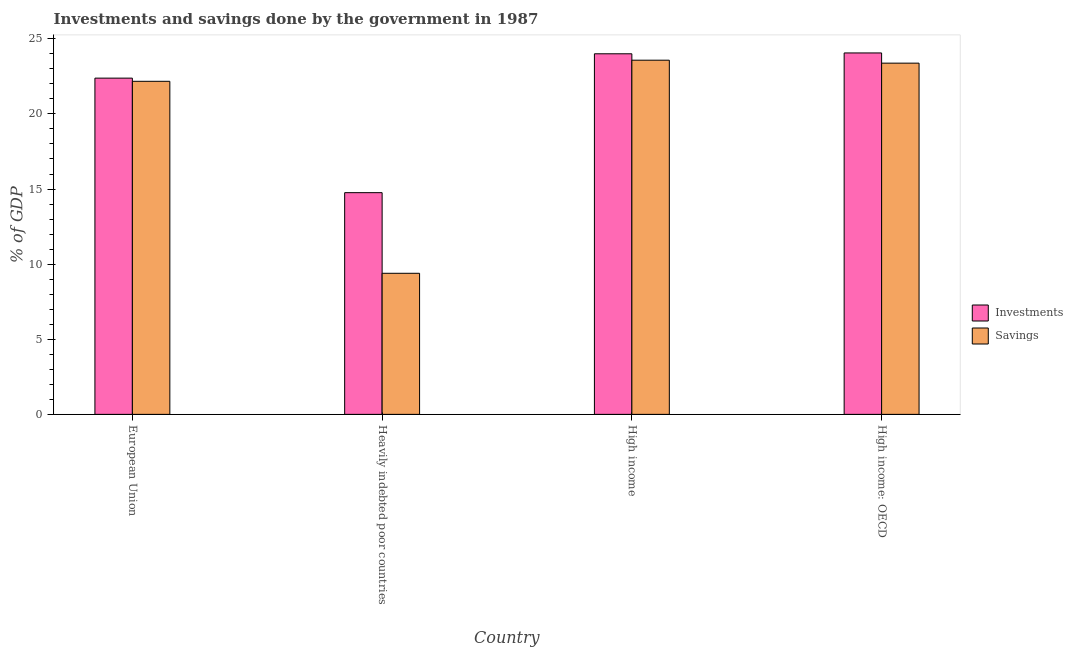How many different coloured bars are there?
Provide a short and direct response. 2. Are the number of bars per tick equal to the number of legend labels?
Provide a short and direct response. Yes. Are the number of bars on each tick of the X-axis equal?
Offer a very short reply. Yes. How many bars are there on the 2nd tick from the right?
Make the answer very short. 2. What is the label of the 2nd group of bars from the left?
Keep it short and to the point. Heavily indebted poor countries. What is the savings of government in High income: OECD?
Give a very brief answer. 23.38. Across all countries, what is the maximum savings of government?
Your response must be concise. 23.58. Across all countries, what is the minimum savings of government?
Ensure brevity in your answer.  9.39. In which country was the investments of government maximum?
Your response must be concise. High income: OECD. In which country was the savings of government minimum?
Offer a very short reply. Heavily indebted poor countries. What is the total investments of government in the graph?
Offer a very short reply. 85.21. What is the difference between the investments of government in European Union and that in High income: OECD?
Provide a succinct answer. -1.68. What is the difference between the investments of government in European Union and the savings of government in Heavily indebted poor countries?
Offer a terse response. 12.99. What is the average investments of government per country?
Your answer should be very brief. 21.3. What is the difference between the investments of government and savings of government in High income?
Keep it short and to the point. 0.43. What is the ratio of the savings of government in European Union to that in High income: OECD?
Make the answer very short. 0.95. Is the savings of government in European Union less than that in High income: OECD?
Provide a short and direct response. Yes. What is the difference between the highest and the second highest savings of government?
Your answer should be very brief. 0.2. What is the difference between the highest and the lowest savings of government?
Your answer should be very brief. 14.19. In how many countries, is the savings of government greater than the average savings of government taken over all countries?
Keep it short and to the point. 3. What does the 1st bar from the left in High income: OECD represents?
Provide a short and direct response. Investments. What does the 2nd bar from the right in High income represents?
Make the answer very short. Investments. How many bars are there?
Your response must be concise. 8. What is the difference between two consecutive major ticks on the Y-axis?
Ensure brevity in your answer.  5. Does the graph contain grids?
Give a very brief answer. No. How many legend labels are there?
Make the answer very short. 2. How are the legend labels stacked?
Your response must be concise. Vertical. What is the title of the graph?
Offer a terse response. Investments and savings done by the government in 1987. Does "Net National savings" appear as one of the legend labels in the graph?
Ensure brevity in your answer.  No. What is the label or title of the X-axis?
Your answer should be compact. Country. What is the label or title of the Y-axis?
Offer a very short reply. % of GDP. What is the % of GDP in Investments in European Union?
Keep it short and to the point. 22.38. What is the % of GDP of Savings in European Union?
Offer a terse response. 22.17. What is the % of GDP of Investments in Heavily indebted poor countries?
Provide a short and direct response. 14.76. What is the % of GDP of Savings in Heavily indebted poor countries?
Provide a short and direct response. 9.39. What is the % of GDP of Investments in High income?
Your answer should be very brief. 24. What is the % of GDP of Savings in High income?
Your answer should be compact. 23.58. What is the % of GDP in Investments in High income: OECD?
Keep it short and to the point. 24.06. What is the % of GDP of Savings in High income: OECD?
Keep it short and to the point. 23.38. Across all countries, what is the maximum % of GDP in Investments?
Your response must be concise. 24.06. Across all countries, what is the maximum % of GDP of Savings?
Your response must be concise. 23.58. Across all countries, what is the minimum % of GDP in Investments?
Your response must be concise. 14.76. Across all countries, what is the minimum % of GDP in Savings?
Keep it short and to the point. 9.39. What is the total % of GDP in Investments in the graph?
Offer a terse response. 85.2. What is the total % of GDP of Savings in the graph?
Your response must be concise. 78.52. What is the difference between the % of GDP of Investments in European Union and that in Heavily indebted poor countries?
Make the answer very short. 7.62. What is the difference between the % of GDP in Savings in European Union and that in Heavily indebted poor countries?
Your answer should be compact. 12.78. What is the difference between the % of GDP in Investments in European Union and that in High income?
Your answer should be compact. -1.62. What is the difference between the % of GDP in Savings in European Union and that in High income?
Ensure brevity in your answer.  -1.41. What is the difference between the % of GDP of Investments in European Union and that in High income: OECD?
Provide a succinct answer. -1.68. What is the difference between the % of GDP in Savings in European Union and that in High income: OECD?
Provide a succinct answer. -1.21. What is the difference between the % of GDP in Investments in Heavily indebted poor countries and that in High income?
Keep it short and to the point. -9.24. What is the difference between the % of GDP in Savings in Heavily indebted poor countries and that in High income?
Your answer should be very brief. -14.19. What is the difference between the % of GDP in Investments in Heavily indebted poor countries and that in High income: OECD?
Make the answer very short. -9.3. What is the difference between the % of GDP in Savings in Heavily indebted poor countries and that in High income: OECD?
Make the answer very short. -13.99. What is the difference between the % of GDP in Investments in High income and that in High income: OECD?
Make the answer very short. -0.06. What is the difference between the % of GDP of Savings in High income and that in High income: OECD?
Ensure brevity in your answer.  0.2. What is the difference between the % of GDP of Investments in European Union and the % of GDP of Savings in Heavily indebted poor countries?
Keep it short and to the point. 12.99. What is the difference between the % of GDP in Investments in European Union and the % of GDP in Savings in High income?
Your answer should be very brief. -1.19. What is the difference between the % of GDP of Investments in European Union and the % of GDP of Savings in High income: OECD?
Your response must be concise. -1. What is the difference between the % of GDP of Investments in Heavily indebted poor countries and the % of GDP of Savings in High income?
Your answer should be very brief. -8.82. What is the difference between the % of GDP of Investments in Heavily indebted poor countries and the % of GDP of Savings in High income: OECD?
Provide a short and direct response. -8.62. What is the difference between the % of GDP of Investments in High income and the % of GDP of Savings in High income: OECD?
Provide a short and direct response. 0.62. What is the average % of GDP in Investments per country?
Provide a succinct answer. 21.3. What is the average % of GDP in Savings per country?
Your answer should be compact. 19.63. What is the difference between the % of GDP of Investments and % of GDP of Savings in European Union?
Give a very brief answer. 0.21. What is the difference between the % of GDP in Investments and % of GDP in Savings in Heavily indebted poor countries?
Give a very brief answer. 5.37. What is the difference between the % of GDP in Investments and % of GDP in Savings in High income?
Your answer should be compact. 0.43. What is the difference between the % of GDP in Investments and % of GDP in Savings in High income: OECD?
Offer a very short reply. 0.68. What is the ratio of the % of GDP of Investments in European Union to that in Heavily indebted poor countries?
Keep it short and to the point. 1.52. What is the ratio of the % of GDP of Savings in European Union to that in Heavily indebted poor countries?
Provide a succinct answer. 2.36. What is the ratio of the % of GDP in Investments in European Union to that in High income?
Ensure brevity in your answer.  0.93. What is the ratio of the % of GDP of Savings in European Union to that in High income?
Your answer should be compact. 0.94. What is the ratio of the % of GDP of Investments in European Union to that in High income: OECD?
Offer a very short reply. 0.93. What is the ratio of the % of GDP in Savings in European Union to that in High income: OECD?
Offer a very short reply. 0.95. What is the ratio of the % of GDP of Investments in Heavily indebted poor countries to that in High income?
Give a very brief answer. 0.61. What is the ratio of the % of GDP in Savings in Heavily indebted poor countries to that in High income?
Provide a short and direct response. 0.4. What is the ratio of the % of GDP in Investments in Heavily indebted poor countries to that in High income: OECD?
Make the answer very short. 0.61. What is the ratio of the % of GDP in Savings in Heavily indebted poor countries to that in High income: OECD?
Provide a succinct answer. 0.4. What is the ratio of the % of GDP of Savings in High income to that in High income: OECD?
Ensure brevity in your answer.  1.01. What is the difference between the highest and the second highest % of GDP in Investments?
Offer a terse response. 0.06. What is the difference between the highest and the second highest % of GDP in Savings?
Your response must be concise. 0.2. What is the difference between the highest and the lowest % of GDP in Investments?
Your response must be concise. 9.3. What is the difference between the highest and the lowest % of GDP in Savings?
Make the answer very short. 14.19. 